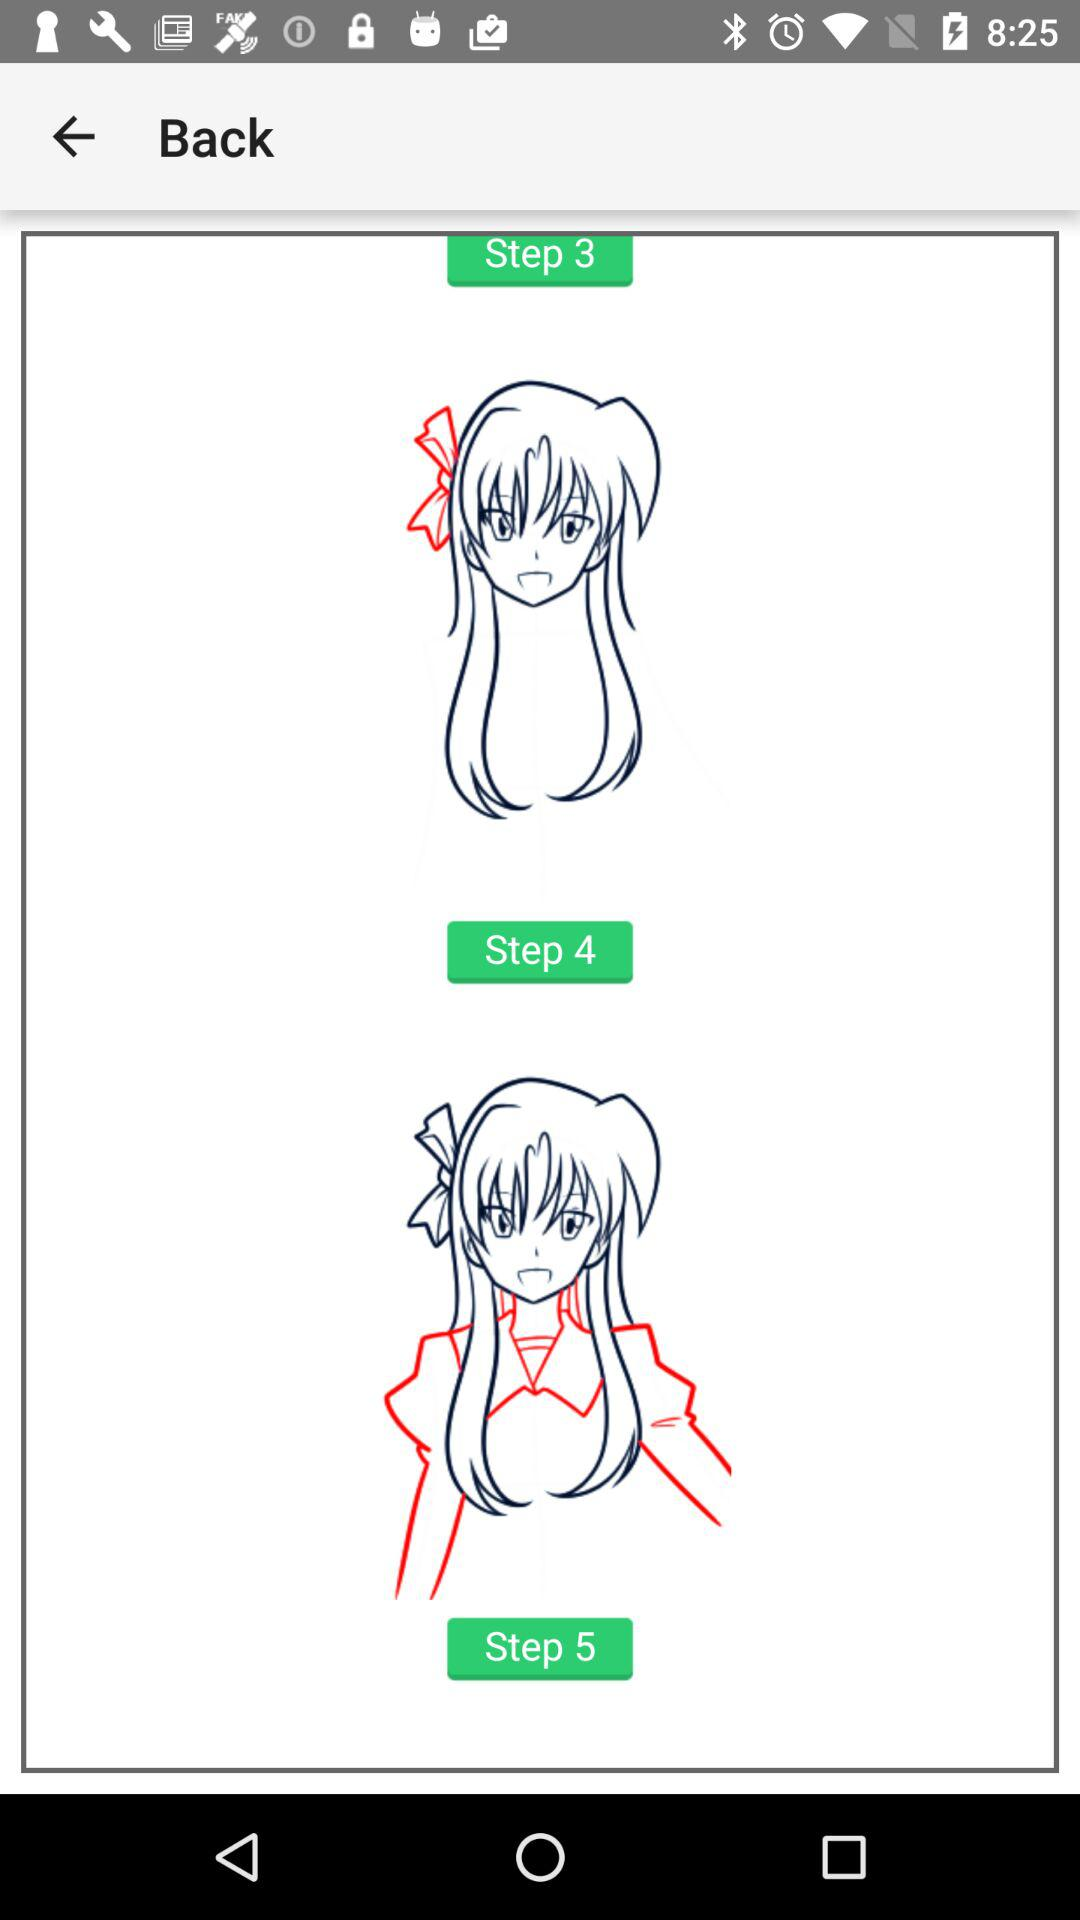How many steps are there in this process?
Answer the question using a single word or phrase. 5 